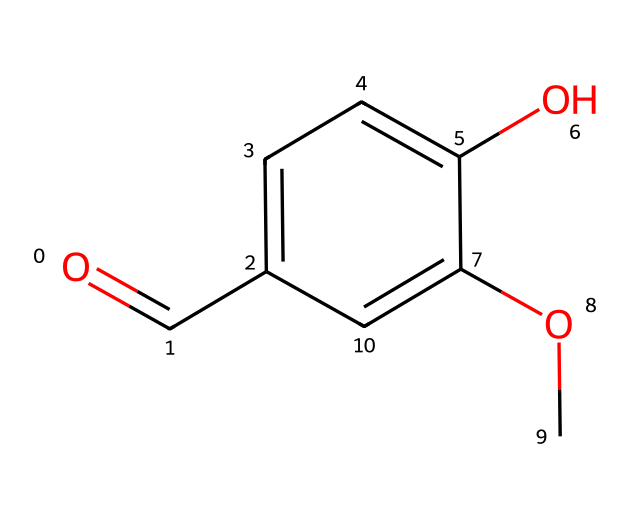How many carbon atoms are in vanillin? The SMILES representation shows multiple 'C' characters, indicating carbon atoms. In the given structure, we can count 8 carbon atoms, which correspond to the backbone and functional groups of the molecule.
Answer: 8 What functional groups are present in vanillin? By analyzing the SMILES, we notice the presence of an aldehyde group (O=C) and an ether group (OC). Thus, vanillin contains these two functional groups.
Answer: aldehyde and ether What is the molecular formula of vanillin? To determine the molecular formula, we can summarize the number of each atom observed in the SMILES: 8 carbons, 8 hydrogens, and 3 oxygens, which leads us to the formula C8H8O3.
Answer: C8H8O3 What type of compound is vanillin classified as? The structure indicates it contains a benzene ring with additional functional groups, classifying it as an aromatic compound. Given that it also has an ether functional group, it falls within the category of aromatic ethers.
Answer: aromatic ether How many oxygen atoms are present in vanillin? The SMILES representation shows the presence of 'O' characters, and counting these indicates that there are three oxygen atoms in the structure of vanillin.
Answer: 3 Does vanillin contain any rings in its structure? The presence of the 'c' notation in the SMILES indicates aromatic carbon atoms that form a cycle, confirming that there is a benzene ring in the structure of vanillin.
Answer: yes In what type of reactions could vanillin participate due to its ether function? Ethers are typically unreactive but can undergo cleavage reactions in the presence of strong acids, suggesting vanillin can participate in reactions involving its ether functional group under specific conditions.
Answer: cleavage reactions 